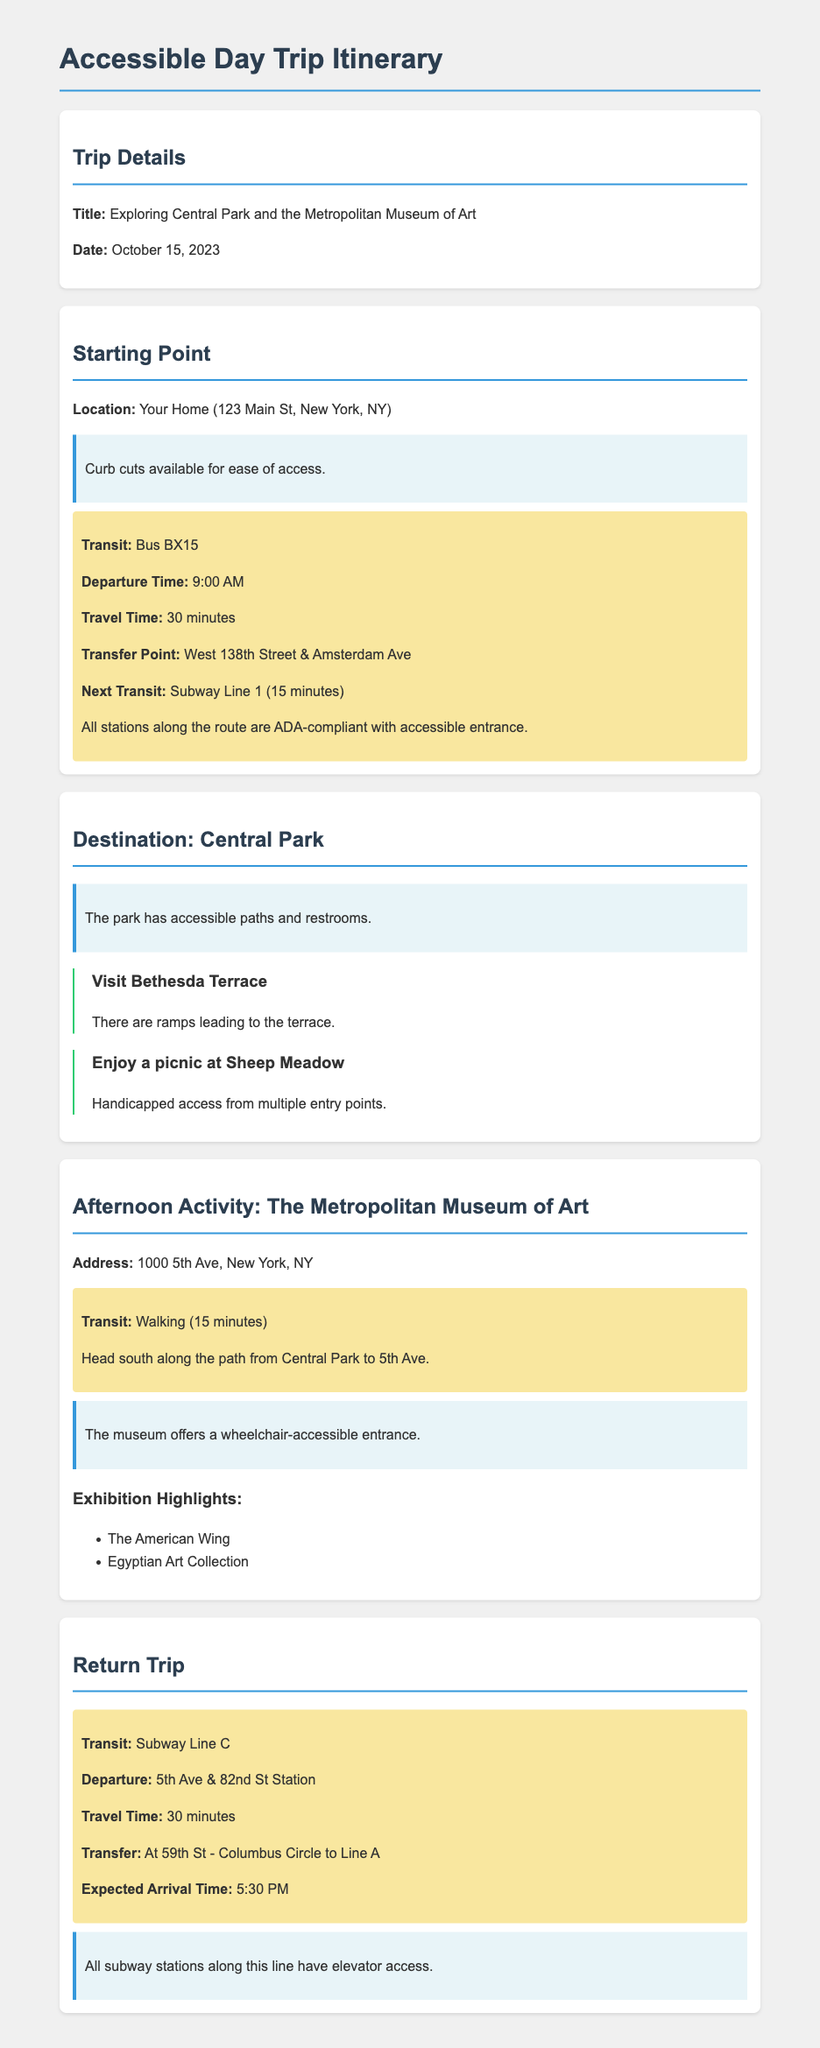What is the title of the trip? The title of the trip is the name given in the document, which is highlighted under "Trip Details."
Answer: Exploring Central Park and the Metropolitan Museum of Art What is the departure time of the first bus? The departure time for the bus is listed under the "Transit" section for the starting point.
Answer: 9:00 AM How long does the bus travel take? The travel time for the bus is specified in the "Transit" details section.
Answer: 30 minutes What is the next transit option after the bus? The next transit option is mentioned after the bus transit information, indicating what comes next.
Answer: Subway Line 1 What accessibility feature is mentioned for the Metropolitan Museum of Art? The museum's accessibility feature is described in the section about the museum visit.
Answer: Wheelchair-accessible entrance How far is the walk from Central Park to the museum? The walking distance is outlined in the "Afternoon Activity" section, indicating the time required.
Answer: 15 minutes What is the transfer point for the return trip? The transfer point for the subway line is noted in the return trip details.
Answer: 59th St - Columbus Circle What time is the expected arrival on the return trip? The expected arrival time is stated in the details for the return trip from the museum.
Answer: 5:30 PM Which bus is taken from the starting point? The bus being taken is specified in the transit information from the starting point.
Answer: Bus BX15 